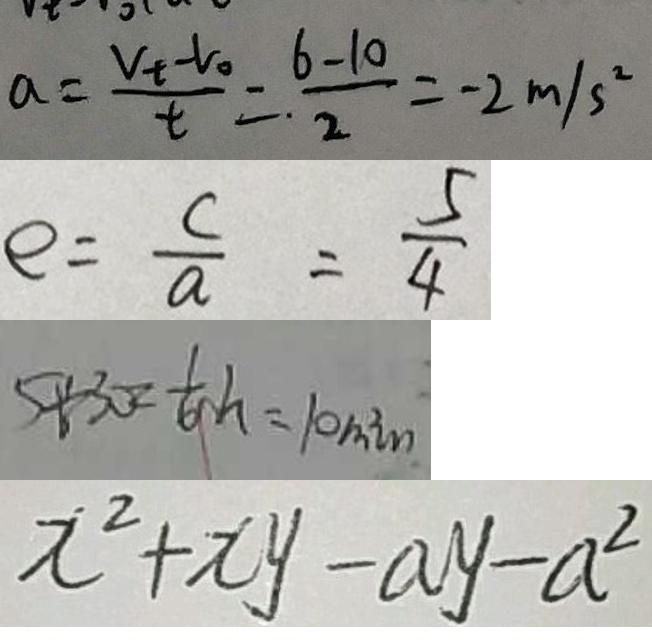<formula> <loc_0><loc_0><loc_500><loc_500>a = \frac { v _ { t } - v _ { 0 } } { t } = \frac { 6 - 1 0 } { 2 } = - 2 m / s ^ { 2 } 
 e = \frac { c } { a } = \frac { 5 } { 4 } 
 5 \div 3 0 = \frac { 1 } { 6 } h = 1 0 \min 
 x ^ { 2 } + x y - a y - a ^ { 2 }</formula> 